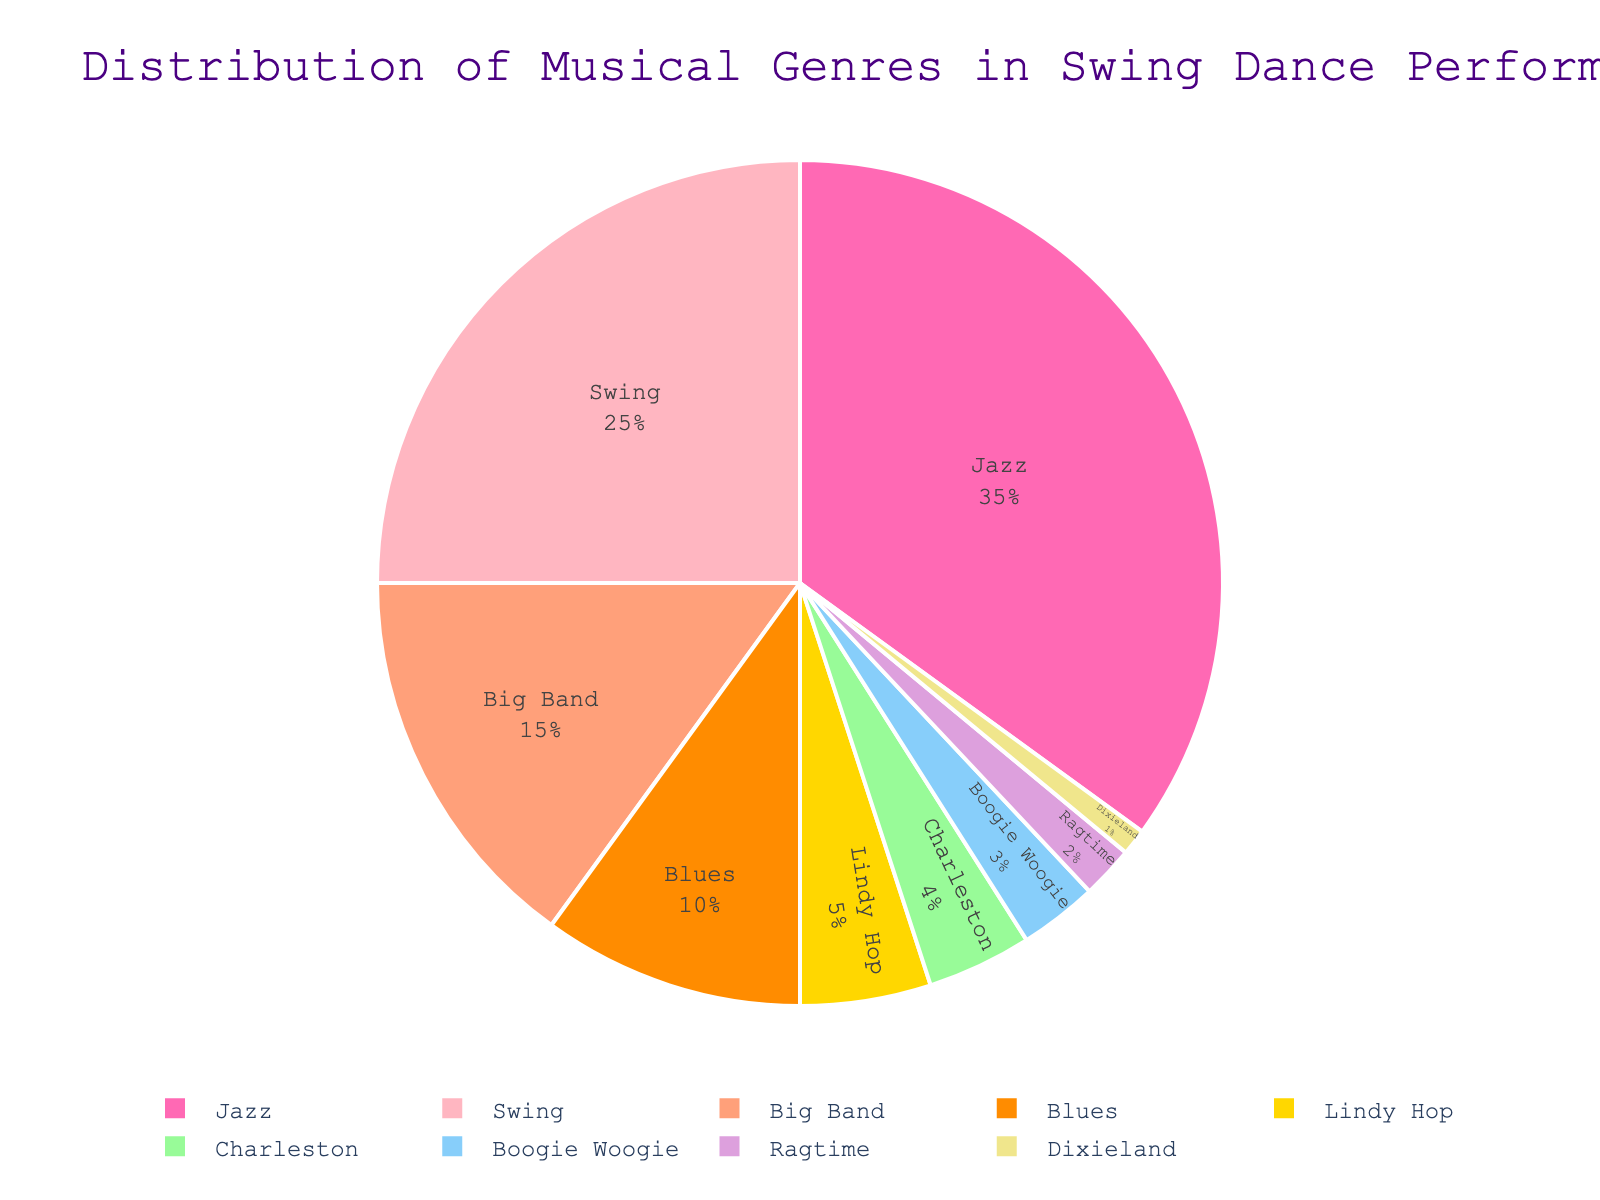What is the most commonly used musical genre in swing dance performances? Explanation: Looking at the pie chart, we can see that the genre with the largest slice represents the most common musical genre. In this case, Jazz has the largest percentage.
Answer: Jazz What's the combined percentage of Jazz and Swing music used in swing dance performances? Explanation: To find the combined percentage, sum the individual percentages for Jazz and Swing. Jazz is 35%, and Swing is 25%, so 35% + 25% = 60%.
Answer: 60% Which genre has a smaller percentage: Boogie Woogie or Ragtime? Explanation: Compare the slices representing Boogie Woogie and Ragtime. Boogie Woogie has 3%, while Ragtime has 2%. Therefore, Ragtime has the smaller percentage.
Answer: Ragtime How does the percentage of Big Band music compare to that of Blues? Explanation: Comparing the percentages, Big Band has 15%, and Blues has 10%. Big Band has a higher percentage than Blues.
Answer: Big Band has a higher percentage than Blues What is the cumulative percentage of all genres with less than 5% each? Explanation: Sum the percentages of genres with less than 5% each: Lindy Hop (5%), Charleston (4%), Boogie Woogie (3%), Ragtime (2%), and Dixieland (1%). 5% + 4% + 3% + 2% + 1% = 15%.
Answer: 15% By how much does the percentage of Jazz exceed the percentage of Big Band music? Explanation: Subtract the percentage of Big Band from the percentage of Jazz. Jazz is 35%, and Big Band is 15%, so 35% - 15% = 20%.
Answer: 20% What is the average percentage of Swing and Blues music? Explanation: To find the average percentage, add the percentages of Swing (25%) and Blues (10%) and then divide by the number of genres (2). (25% + 10%) / 2 = 17.5%.
Answer: 17.5% Which genres have a percentage that, when combined, equals the percentage of Swing music alone? Explanation: Swing music has a 25% share. Looking at the smaller categories, the sum of Big Band (15%) and Blues (10%) equals 25%.
Answer: Big Band and Blues Considering only the genres Jazz, Swing, and Blues, what percentage of the total do they account for? Explanation: Sum the percentages of Jazz (35%), Swing (25%), and Blues (10%). 35% + 25% + 10% = 70%.
Answer: 70% What is the ratio of the percentage of Lindy Hop music to the percentage of Charleston music? Explanation: Lindy Hop has 5%, and Charleston has 4%. The ratio is 5:4.
Answer: 5:4 